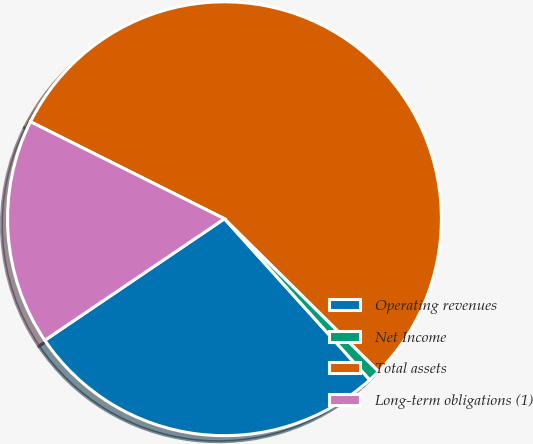Convert chart to OTSL. <chart><loc_0><loc_0><loc_500><loc_500><pie_chart><fcel>Operating revenues<fcel>Net Income<fcel>Total assets<fcel>Long-term obligations (1)<nl><fcel>27.21%<fcel>0.9%<fcel>55.04%<fcel>16.85%<nl></chart> 